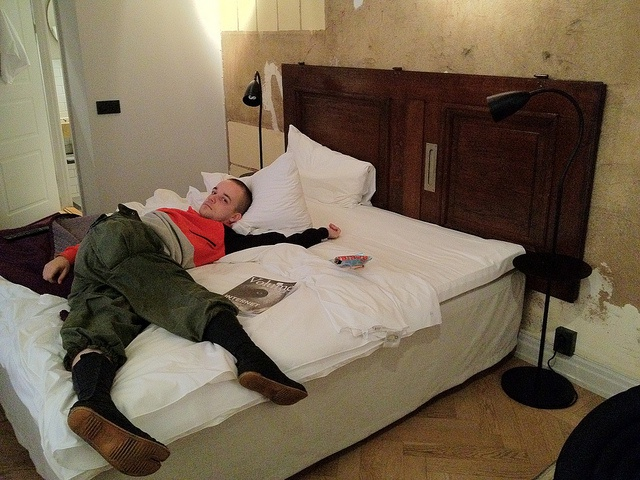Describe the objects in this image and their specific colors. I can see bed in tan, darkgray, gray, and black tones, people in tan, black, maroon, gray, and brown tones, and book in tan, maroon, and gray tones in this image. 